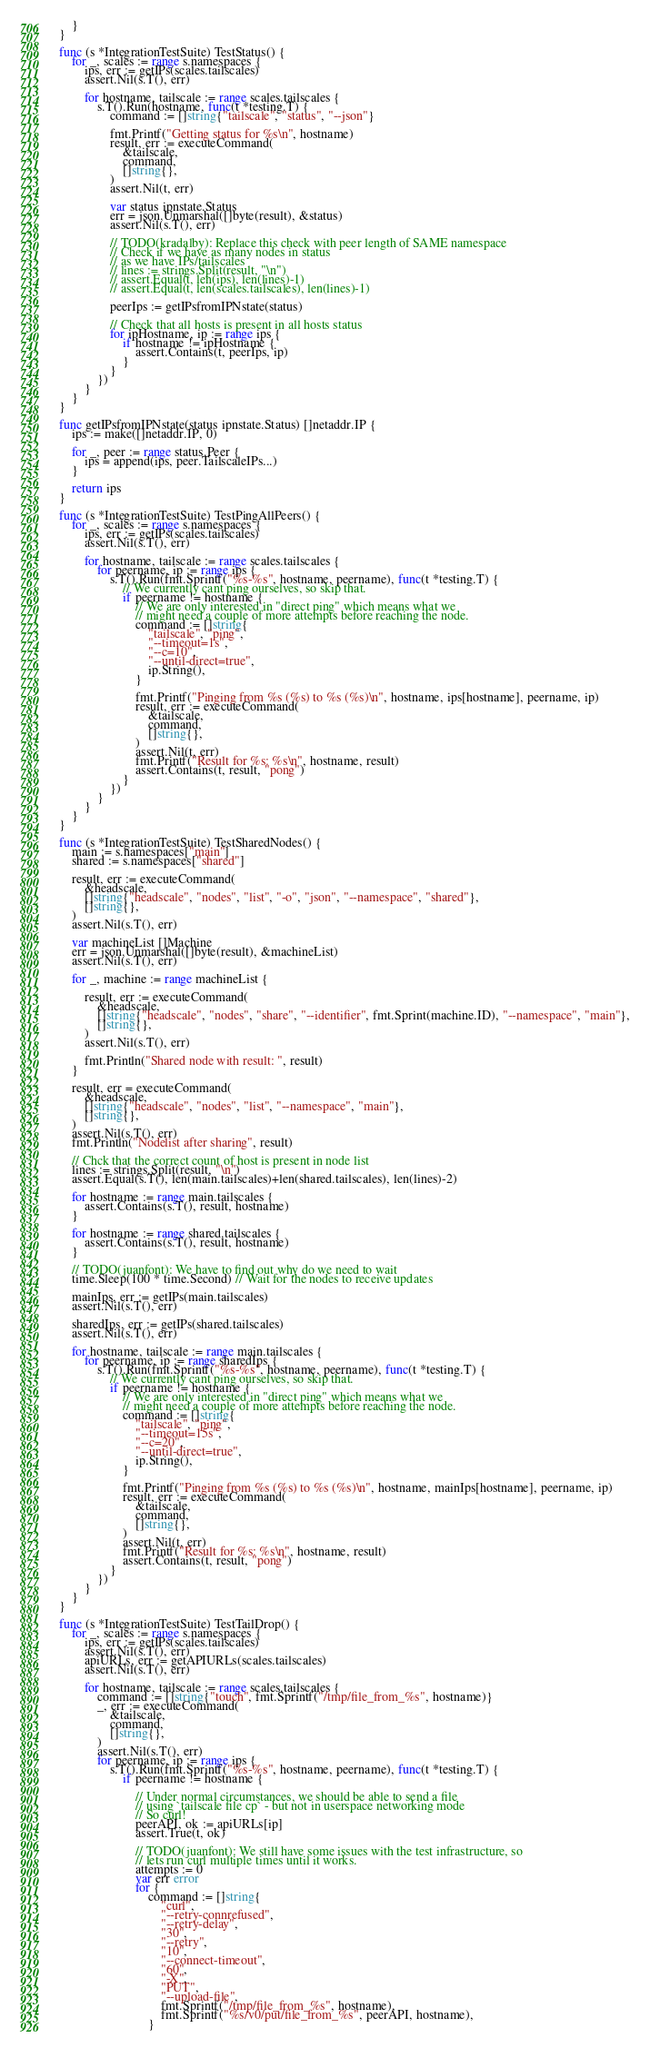<code> <loc_0><loc_0><loc_500><loc_500><_Go_>	}
}

func (s *IntegrationTestSuite) TestStatus() {
	for _, scales := range s.namespaces {
		ips, err := getIPs(scales.tailscales)
		assert.Nil(s.T(), err)

		for hostname, tailscale := range scales.tailscales {
			s.T().Run(hostname, func(t *testing.T) {
				command := []string{"tailscale", "status", "--json"}

				fmt.Printf("Getting status for %s\n", hostname)
				result, err := executeCommand(
					&tailscale,
					command,
					[]string{},
				)
				assert.Nil(t, err)

				var status ipnstate.Status
				err = json.Unmarshal([]byte(result), &status)
				assert.Nil(s.T(), err)

				// TODO(kradalby): Replace this check with peer length of SAME namespace
				// Check if we have as many nodes in status
				// as we have IPs/tailscales
				// lines := strings.Split(result, "\n")
				// assert.Equal(t, len(ips), len(lines)-1)
				// assert.Equal(t, len(scales.tailscales), len(lines)-1)

				peerIps := getIPsfromIPNstate(status)

				// Check that all hosts is present in all hosts status
				for ipHostname, ip := range ips {
					if hostname != ipHostname {
						assert.Contains(t, peerIps, ip)
					}
				}
			})
		}
	}
}

func getIPsfromIPNstate(status ipnstate.Status) []netaddr.IP {
	ips := make([]netaddr.IP, 0)

	for _, peer := range status.Peer {
		ips = append(ips, peer.TailscaleIPs...)
	}

	return ips
}

func (s *IntegrationTestSuite) TestPingAllPeers() {
	for _, scales := range s.namespaces {
		ips, err := getIPs(scales.tailscales)
		assert.Nil(s.T(), err)

		for hostname, tailscale := range scales.tailscales {
			for peername, ip := range ips {
				s.T().Run(fmt.Sprintf("%s-%s", hostname, peername), func(t *testing.T) {
					// We currently cant ping ourselves, so skip that.
					if peername != hostname {
						// We are only interested in "direct ping" which means what we
						// might need a couple of more attempts before reaching the node.
						command := []string{
							"tailscale", "ping",
							"--timeout=1s",
							"--c=10",
							"--until-direct=true",
							ip.String(),
						}

						fmt.Printf("Pinging from %s (%s) to %s (%s)\n", hostname, ips[hostname], peername, ip)
						result, err := executeCommand(
							&tailscale,
							command,
							[]string{},
						)
						assert.Nil(t, err)
						fmt.Printf("Result for %s: %s\n", hostname, result)
						assert.Contains(t, result, "pong")
					}
				})
			}
		}
	}
}

func (s *IntegrationTestSuite) TestSharedNodes() {
	main := s.namespaces["main"]
	shared := s.namespaces["shared"]

	result, err := executeCommand(
		&headscale,
		[]string{"headscale", "nodes", "list", "-o", "json", "--namespace", "shared"},
		[]string{},
	)
	assert.Nil(s.T(), err)

	var machineList []Machine
	err = json.Unmarshal([]byte(result), &machineList)
	assert.Nil(s.T(), err)

	for _, machine := range machineList {

		result, err := executeCommand(
			&headscale,
			[]string{"headscale", "nodes", "share", "--identifier", fmt.Sprint(machine.ID), "--namespace", "main"},
			[]string{},
		)
		assert.Nil(s.T(), err)

		fmt.Println("Shared node with result: ", result)
	}

	result, err = executeCommand(
		&headscale,
		[]string{"headscale", "nodes", "list", "--namespace", "main"},
		[]string{},
	)
	assert.Nil(s.T(), err)
	fmt.Println("Nodelist after sharing", result)

	// Chck that the correct count of host is present in node list
	lines := strings.Split(result, "\n")
	assert.Equal(s.T(), len(main.tailscales)+len(shared.tailscales), len(lines)-2)

	for hostname := range main.tailscales {
		assert.Contains(s.T(), result, hostname)
	}

	for hostname := range shared.tailscales {
		assert.Contains(s.T(), result, hostname)
	}

	// TODO(juanfont): We have to find out why do we need to wait
	time.Sleep(100 * time.Second) // Wait for the nodes to receive updates

	mainIps, err := getIPs(main.tailscales)
	assert.Nil(s.T(), err)

	sharedIps, err := getIPs(shared.tailscales)
	assert.Nil(s.T(), err)

	for hostname, tailscale := range main.tailscales {
		for peername, ip := range sharedIps {
			s.T().Run(fmt.Sprintf("%s-%s", hostname, peername), func(t *testing.T) {
				// We currently cant ping ourselves, so skip that.
				if peername != hostname {
					// We are only interested in "direct ping" which means what we
					// might need a couple of more attempts before reaching the node.
					command := []string{
						"tailscale", "ping",
						"--timeout=15s",
						"--c=20",
						"--until-direct=true",
						ip.String(),
					}

					fmt.Printf("Pinging from %s (%s) to %s (%s)\n", hostname, mainIps[hostname], peername, ip)
					result, err := executeCommand(
						&tailscale,
						command,
						[]string{},
					)
					assert.Nil(t, err)
					fmt.Printf("Result for %s: %s\n", hostname, result)
					assert.Contains(t, result, "pong")
				}
			})
		}
	}
}

func (s *IntegrationTestSuite) TestTailDrop() {
	for _, scales := range s.namespaces {
		ips, err := getIPs(scales.tailscales)
		assert.Nil(s.T(), err)
		apiURLs, err := getAPIURLs(scales.tailscales)
		assert.Nil(s.T(), err)

		for hostname, tailscale := range scales.tailscales {
			command := []string{"touch", fmt.Sprintf("/tmp/file_from_%s", hostname)}
			_, err := executeCommand(
				&tailscale,
				command,
				[]string{},
			)
			assert.Nil(s.T(), err)
			for peername, ip := range ips {
				s.T().Run(fmt.Sprintf("%s-%s", hostname, peername), func(t *testing.T) {
					if peername != hostname {

						// Under normal circumstances, we should be able to send a file
						// using `tailscale file cp` - but not in userspace networking mode
						// So curl!
						peerAPI, ok := apiURLs[ip]
						assert.True(t, ok)

						// TODO(juanfont): We still have some issues with the test infrastructure, so
						// lets run curl multiple times until it works.
						attempts := 0
						var err error
						for {
							command := []string{
								"curl",
								"--retry-connrefused",
								"--retry-delay",
								"30",
								"--retry",
								"10",
								"--connect-timeout",
								"60",
								"-X",
								"PUT",
								"--upload-file",
								fmt.Sprintf("/tmp/file_from_%s", hostname),
								fmt.Sprintf("%s/v0/put/file_from_%s", peerAPI, hostname),
							}</code> 